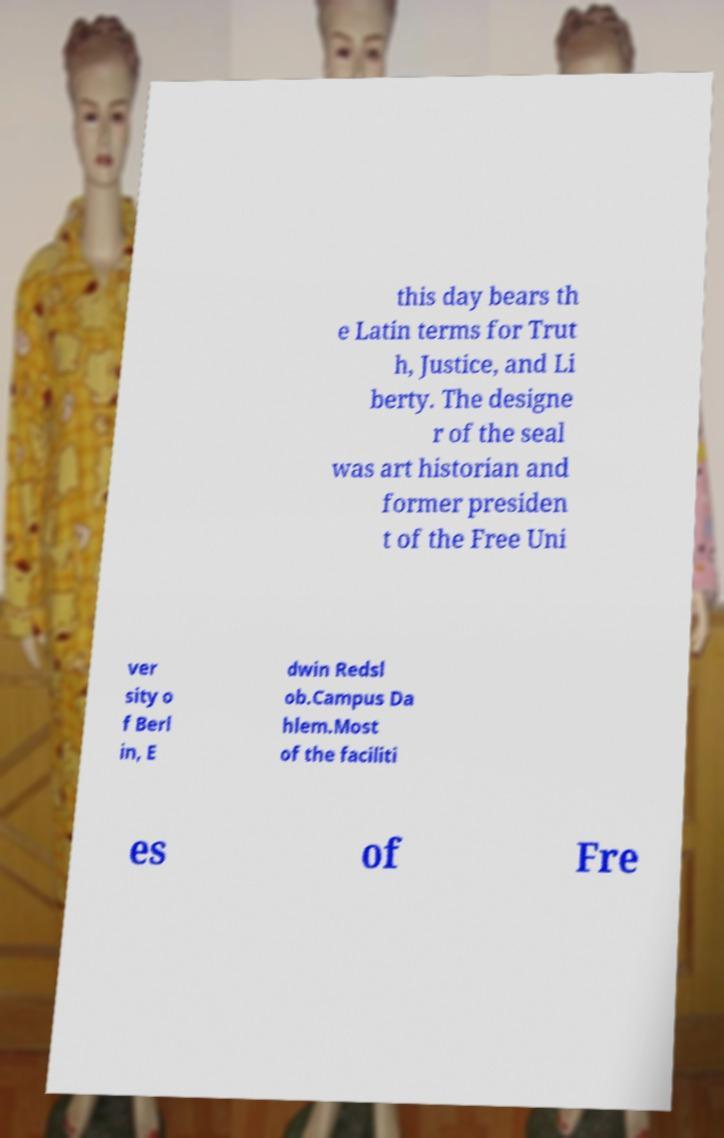Could you assist in decoding the text presented in this image and type it out clearly? this day bears th e Latin terms for Trut h, Justice, and Li berty. The designe r of the seal was art historian and former presiden t of the Free Uni ver sity o f Berl in, E dwin Redsl ob.Campus Da hlem.Most of the faciliti es of Fre 